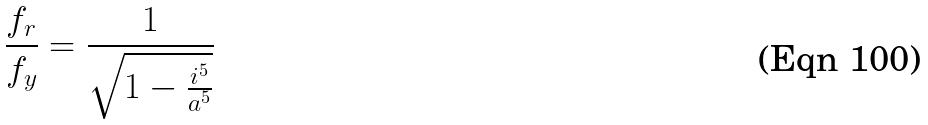Convert formula to latex. <formula><loc_0><loc_0><loc_500><loc_500>\frac { f _ { r } } { f _ { y } } = \frac { 1 } { \sqrt { 1 - \frac { i ^ { 5 } } { a ^ { 5 } } } }</formula> 